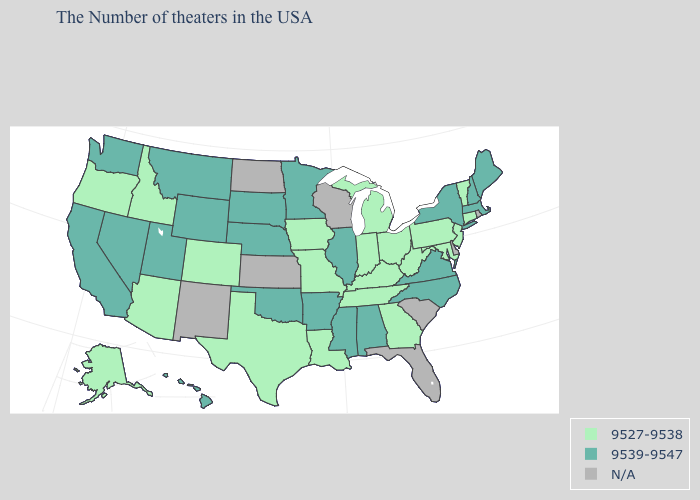Which states have the highest value in the USA?
Answer briefly. Maine, Massachusetts, New Hampshire, New York, Virginia, North Carolina, Alabama, Illinois, Mississippi, Arkansas, Minnesota, Nebraska, Oklahoma, South Dakota, Wyoming, Utah, Montana, Nevada, California, Washington, Hawaii. What is the value of Tennessee?
Write a very short answer. 9527-9538. What is the highest value in the USA?
Write a very short answer. 9539-9547. Among the states that border Nebraska , does Colorado have the highest value?
Be succinct. No. What is the highest value in the MidWest ?
Concise answer only. 9539-9547. Does the first symbol in the legend represent the smallest category?
Answer briefly. Yes. Which states hav the highest value in the South?
Be succinct. Virginia, North Carolina, Alabama, Mississippi, Arkansas, Oklahoma. What is the value of Washington?
Concise answer only. 9539-9547. Name the states that have a value in the range 9527-9538?
Be succinct. Vermont, Connecticut, New Jersey, Maryland, Pennsylvania, West Virginia, Ohio, Georgia, Michigan, Kentucky, Indiana, Tennessee, Louisiana, Missouri, Iowa, Texas, Colorado, Arizona, Idaho, Oregon, Alaska. Does the first symbol in the legend represent the smallest category?
Answer briefly. Yes. What is the value of Texas?
Quick response, please. 9527-9538. What is the value of Vermont?
Concise answer only. 9527-9538. Among the states that border Georgia , which have the lowest value?
Keep it brief. Tennessee. Does Washington have the highest value in the West?
Give a very brief answer. Yes. 